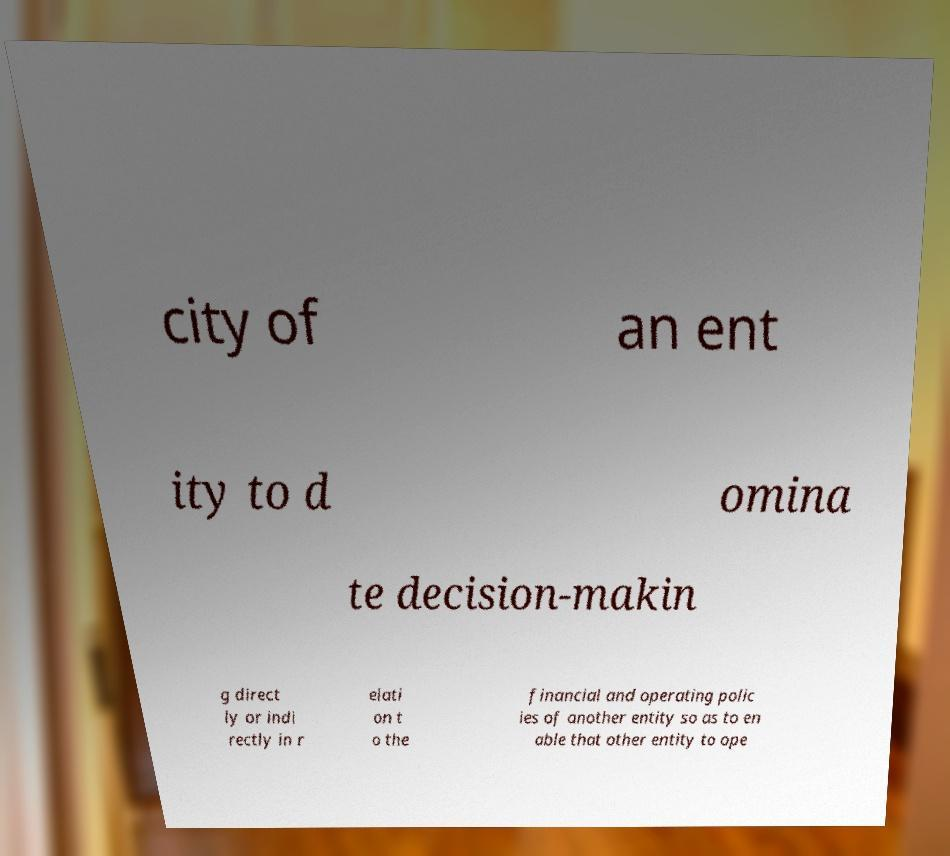Could you extract and type out the text from this image? city of an ent ity to d omina te decision-makin g direct ly or indi rectly in r elati on t o the financial and operating polic ies of another entity so as to en able that other entity to ope 